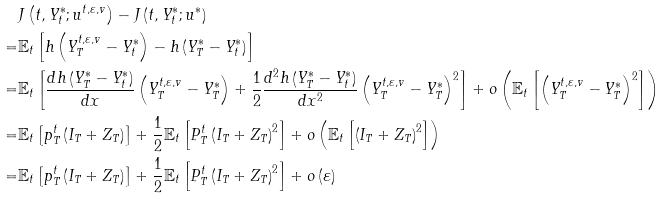Convert formula to latex. <formula><loc_0><loc_0><loc_500><loc_500>& J \left ( t , Y _ { t } ^ { * } ; u ^ { t , \varepsilon , v } \right ) - J \left ( t , Y _ { t } ^ { * } ; u ^ { * } \right ) \\ = & \mathbb { E } _ { t } \left [ h \left ( Y _ { T } ^ { t , \varepsilon , v } - Y _ { t } ^ { * } \right ) - h \left ( Y _ { T } ^ { * } - Y _ { t } ^ { * } \right ) \right ] \\ = & \mathbb { E } _ { t } \left [ \frac { d h \left ( Y _ { T } ^ { * } - Y _ { t } ^ { * } \right ) } { d x } \left ( Y _ { T } ^ { t , \varepsilon , v } - Y _ { T } ^ { * } \right ) + \frac { 1 } { 2 } \frac { d ^ { 2 } h \left ( Y _ { T } ^ { * } - Y _ { t } ^ { * } \right ) } { d x ^ { 2 } } \left ( Y _ { T } ^ { t , \varepsilon , v } - Y _ { T } ^ { * } \right ) ^ { 2 } \right ] + o \left ( \mathbb { E } _ { t } \left [ \left ( Y _ { T } ^ { t , \varepsilon , v } - Y _ { T } ^ { * } \right ) ^ { 2 } \right ] \right ) \\ = & \mathbb { E } _ { t } \left [ p _ { T } ^ { t } \left ( I _ { T } + Z _ { T } \right ) \right ] + \frac { 1 } { 2 } \mathbb { E } _ { t } \left [ P _ { T } ^ { t } \left ( I _ { T } + Z _ { T } \right ) ^ { 2 } \right ] + o \left ( \mathbb { E } _ { t } \left [ \left ( I _ { T } + Z _ { T } \right ) ^ { 2 } \right ] \right ) \\ = & \mathbb { E } _ { t } \left [ p _ { T } ^ { t } \left ( I _ { T } + Z _ { T } \right ) \right ] + \frac { 1 } { 2 } \mathbb { E } _ { t } \left [ P _ { T } ^ { t } \left ( I _ { T } + Z _ { T } \right ) ^ { 2 } \right ] + o \left ( \varepsilon \right )</formula> 